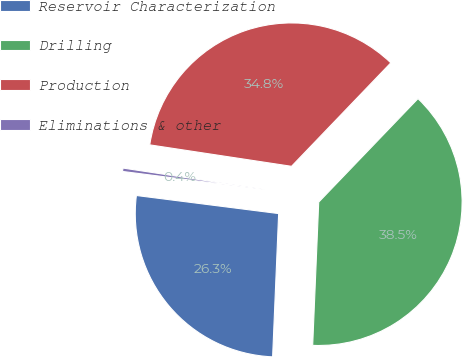Convert chart to OTSL. <chart><loc_0><loc_0><loc_500><loc_500><pie_chart><fcel>Reservoir Characterization<fcel>Drilling<fcel>Production<fcel>Eliminations & other<nl><fcel>26.34%<fcel>38.5%<fcel>34.78%<fcel>0.38%<nl></chart> 